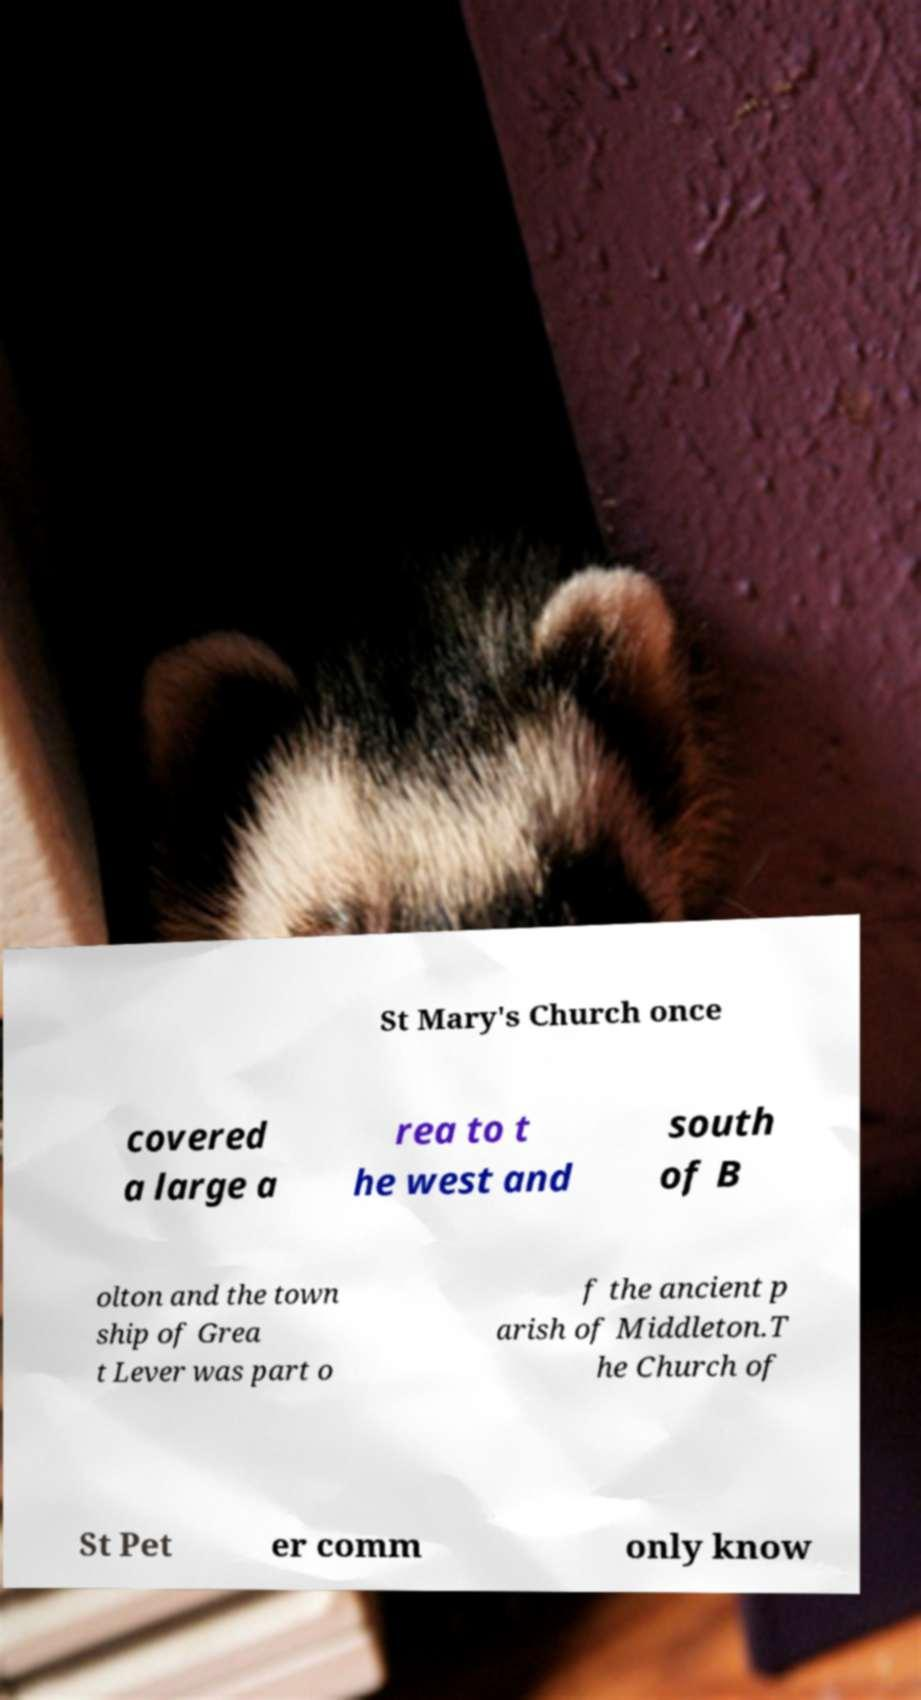Could you extract and type out the text from this image? St Mary's Church once covered a large a rea to t he west and south of B olton and the town ship of Grea t Lever was part o f the ancient p arish of Middleton.T he Church of St Pet er comm only know 